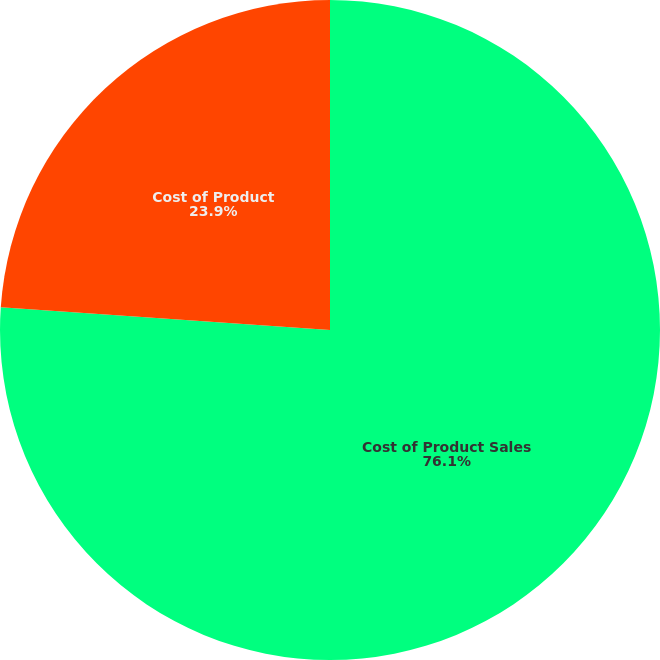Convert chart to OTSL. <chart><loc_0><loc_0><loc_500><loc_500><pie_chart><fcel>Cost of Product Sales<fcel>Cost of Product<nl><fcel>76.1%<fcel>23.9%<nl></chart> 